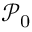<formula> <loc_0><loc_0><loc_500><loc_500>\mathcal { P } _ { 0 }</formula> 